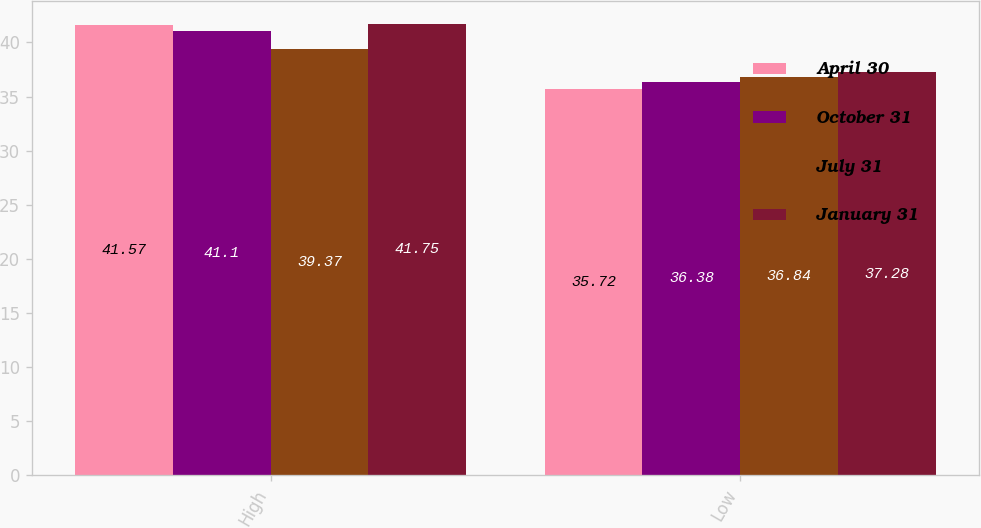Convert chart to OTSL. <chart><loc_0><loc_0><loc_500><loc_500><stacked_bar_chart><ecel><fcel>High<fcel>Low<nl><fcel>April 30<fcel>41.57<fcel>35.72<nl><fcel>October 31<fcel>41.1<fcel>36.38<nl><fcel>July 31<fcel>39.37<fcel>36.84<nl><fcel>January 31<fcel>41.75<fcel>37.28<nl></chart> 